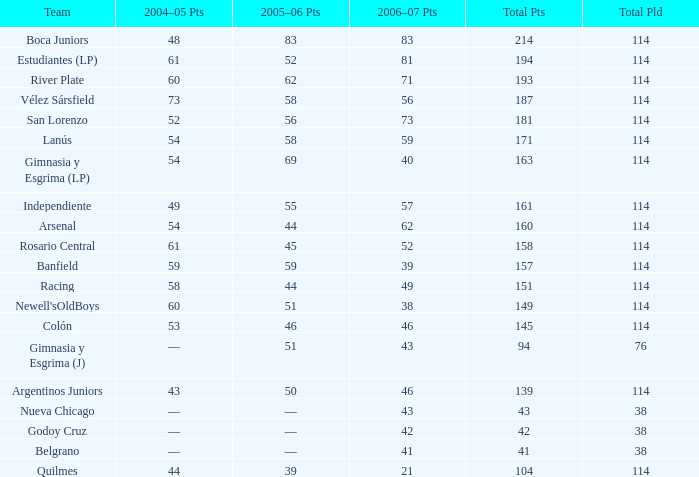Can you give me this table as a dict? {'header': ['Team', '2004–05 Pts', '2005–06 Pts', '2006–07 Pts', 'Total Pts', 'Total Pld'], 'rows': [['Boca Juniors', '48', '83', '83', '214', '114'], ['Estudiantes (LP)', '61', '52', '81', '194', '114'], ['River Plate', '60', '62', '71', '193', '114'], ['Vélez Sársfield', '73', '58', '56', '187', '114'], ['San Lorenzo', '52', '56', '73', '181', '114'], ['Lanús', '54', '58', '59', '171', '114'], ['Gimnasia y Esgrima (LP)', '54', '69', '40', '163', '114'], ['Independiente', '49', '55', '57', '161', '114'], ['Arsenal', '54', '44', '62', '160', '114'], ['Rosario Central', '61', '45', '52', '158', '114'], ['Banfield', '59', '59', '39', '157', '114'], ['Racing', '58', '44', '49', '151', '114'], ["Newell'sOldBoys", '60', '51', '38', '149', '114'], ['Colón', '53', '46', '46', '145', '114'], ['Gimnasia y Esgrima (J)', '—', '51', '43', '94', '76'], ['Argentinos Juniors', '43', '50', '46', '139', '114'], ['Nueva Chicago', '—', '—', '43', '43', '38'], ['Godoy Cruz', '—', '—', '42', '42', '38'], ['Belgrano', '—', '—', '41', '41', '38'], ['Quilmes', '44', '39', '21', '104', '114']]} What is the overall count of pld for team arsenal? 1.0. 